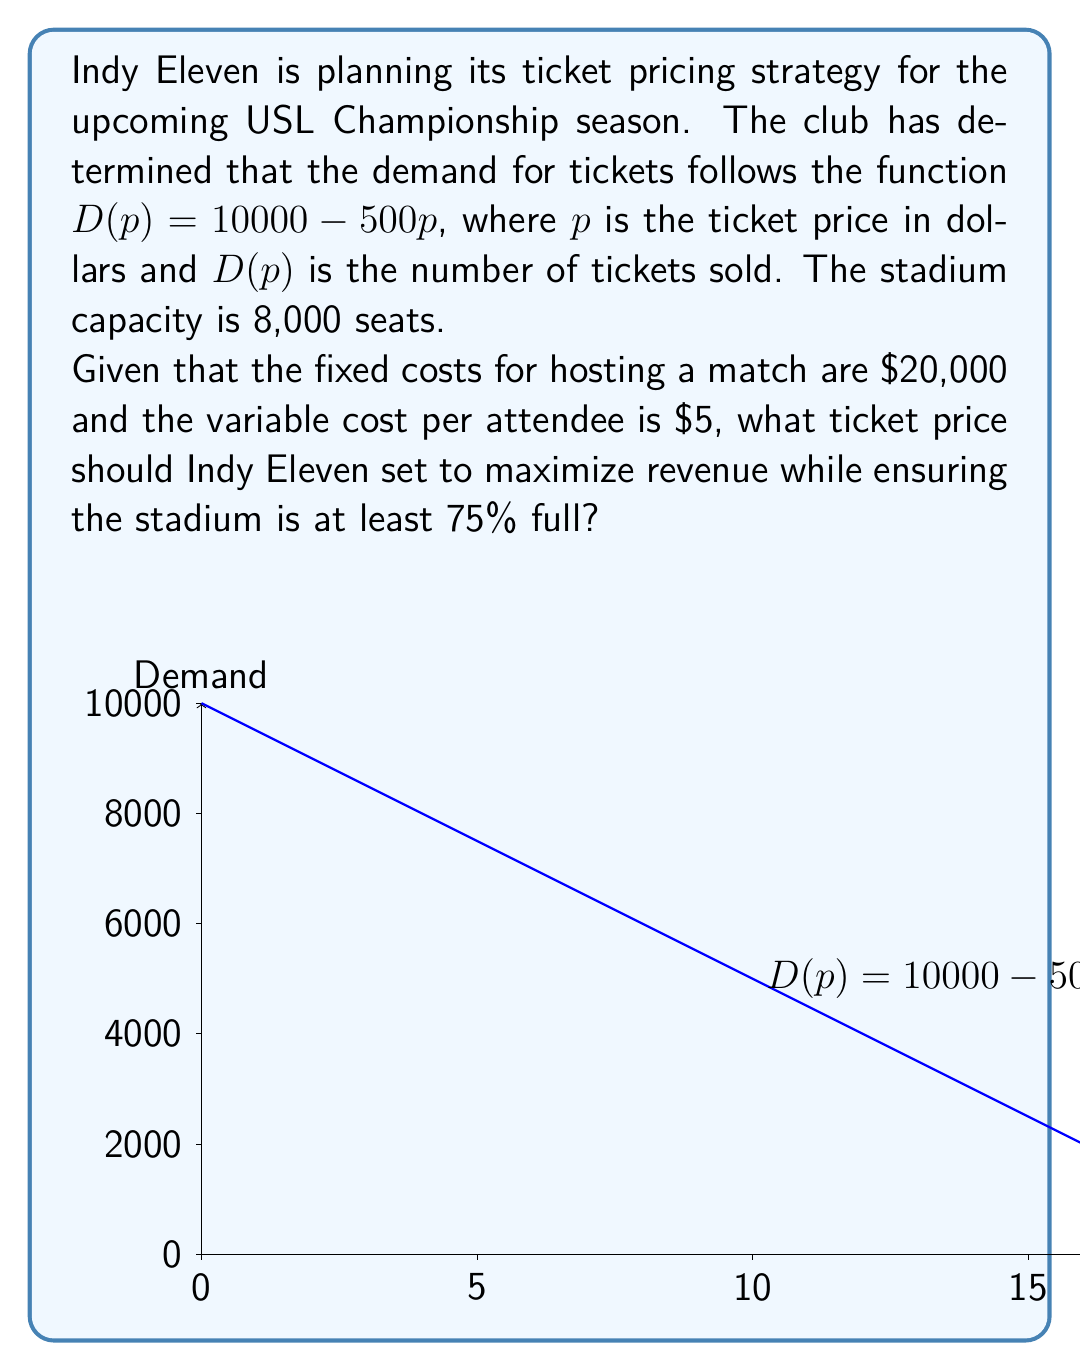Solve this math problem. Let's approach this step-by-step:

1) First, we need to set up the revenue function. Revenue is price times quantity:
   $R(p) = p \cdot D(p) = p(10000 - 500p) = 10000p - 500p^2$

2) To find the maximum revenue, we differentiate R(p) and set it to zero:
   $\frac{dR}{dp} = 10000 - 1000p = 0$
   $1000p = 10000$
   $p = 10$

3) This gives us the price that maximizes revenue: $10. However, we need to check if this satisfies the attendance constraint.

4) At $p = 10$, demand would be:
   $D(10) = 10000 - 500(10) = 5000$

5) The stadium capacity is 8,000, and we need it to be at least 75% full:
   $75\% \text{ of } 8000 = 6000$

6) Since 5000 < 6000, the revenue-maximizing price doesn't meet our attendance constraint.

7) To find the price that gives 75% attendance:
   $6000 = 10000 - 500p$
   $4000 = 500p$
   $p = 8$

8) Let's verify the profit at this price:
   Revenue: $8 \cdot 6000 = 48000$
   Costs: $20000 + 5 \cdot 6000 = 50000$
   Profit: $48000 - 50000 = -2000$

9) Despite the negative profit, this is the highest price that meets the attendance constraint.
Answer: $8 